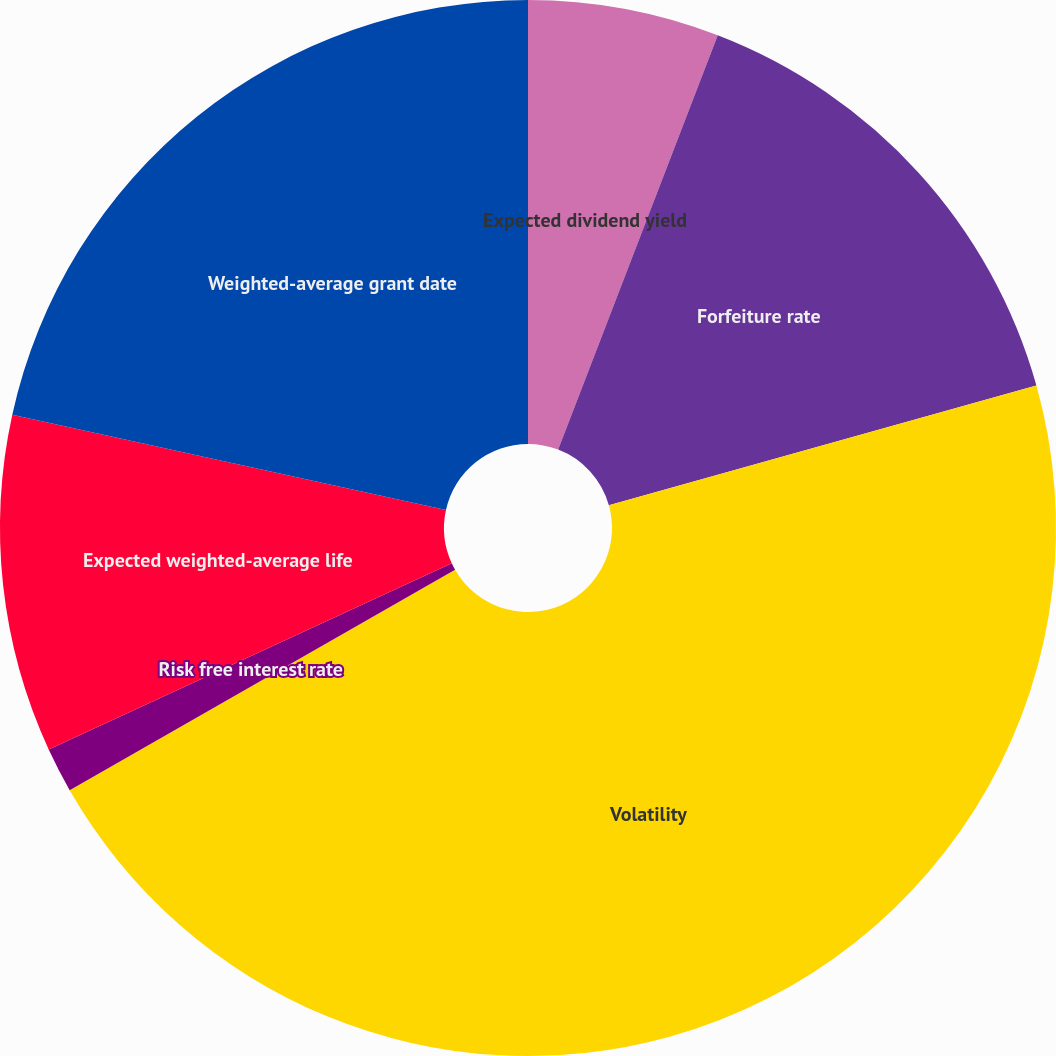Convert chart. <chart><loc_0><loc_0><loc_500><loc_500><pie_chart><fcel>Expected dividend yield<fcel>Forfeiture rate<fcel>Volatility<fcel>Risk free interest rate<fcel>Expected weighted-average life<fcel>Weighted-average grant date<nl><fcel>5.85%<fcel>14.8%<fcel>46.08%<fcel>1.38%<fcel>10.33%<fcel>21.56%<nl></chart> 